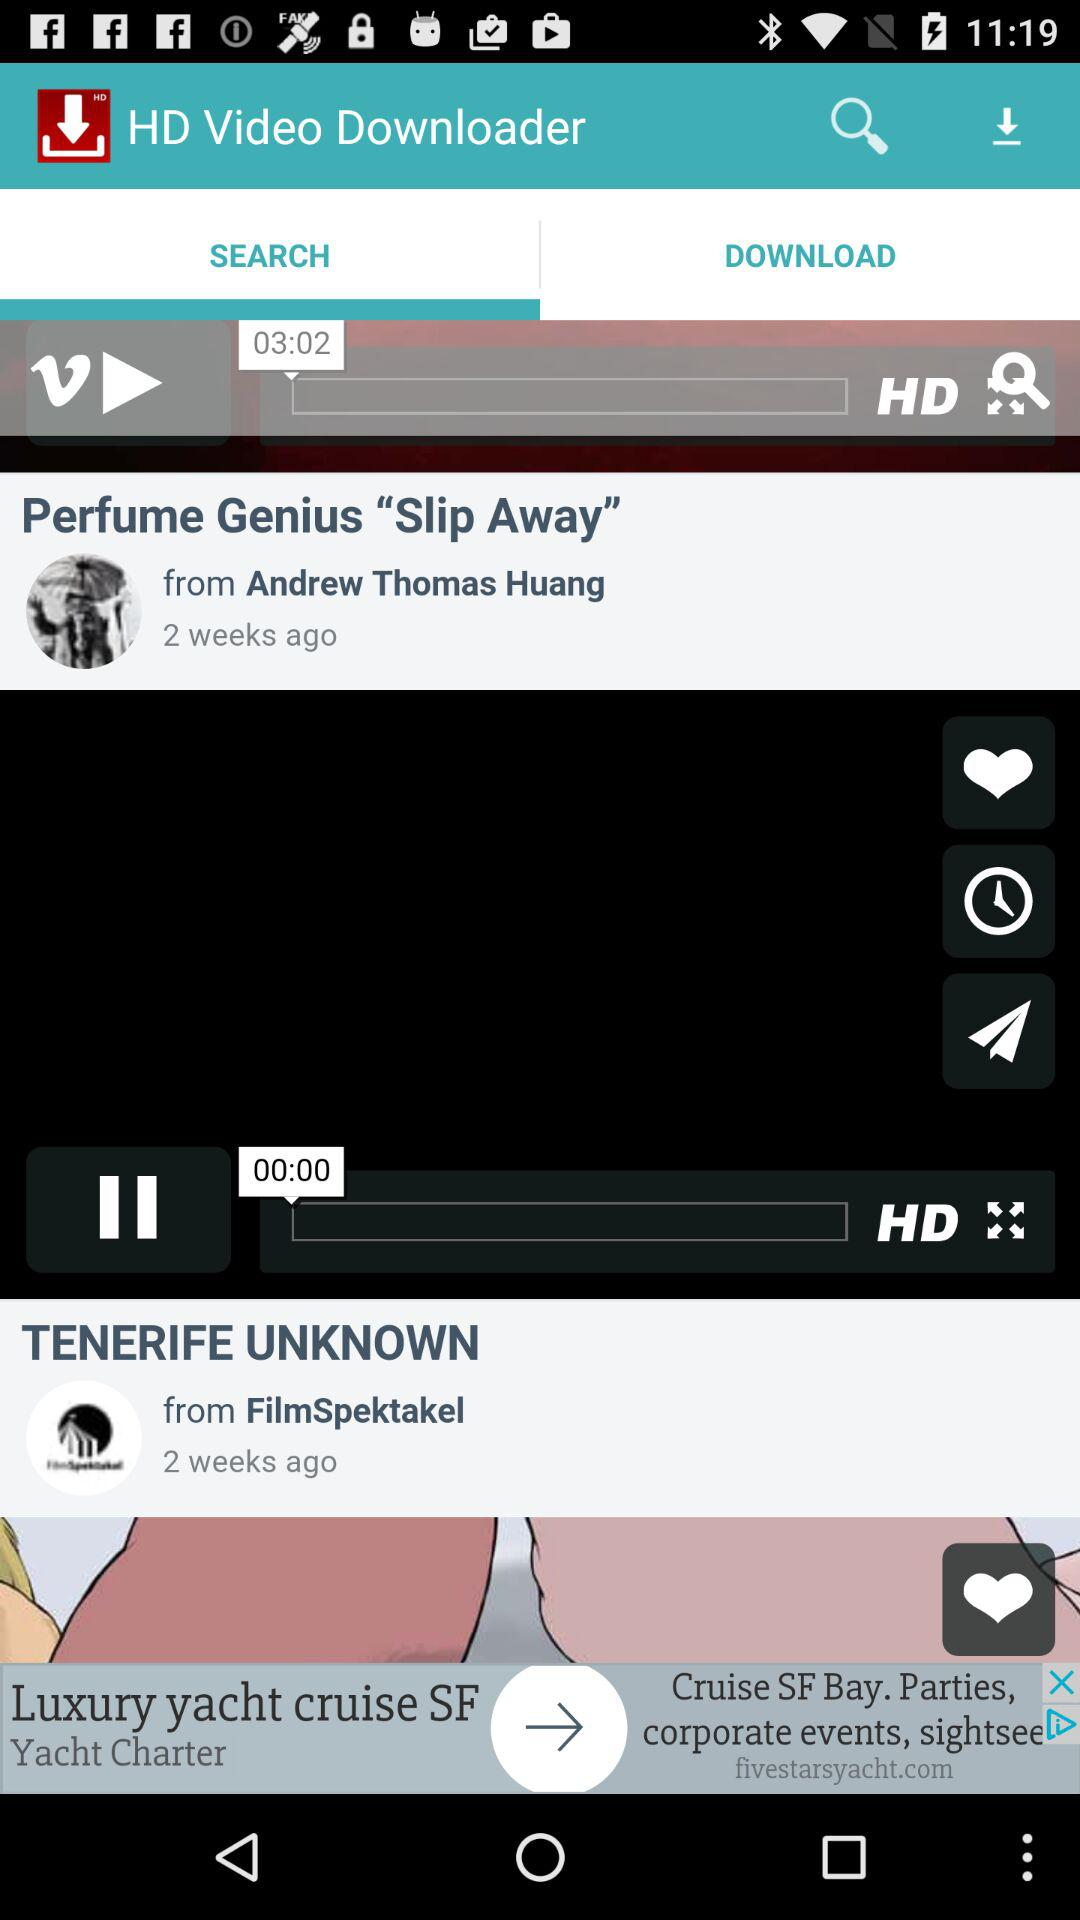When was the "Perfume Genius Slip Away" video posted? The "Perfume Genius Slip Away" video was posted 2 weeks ago. 